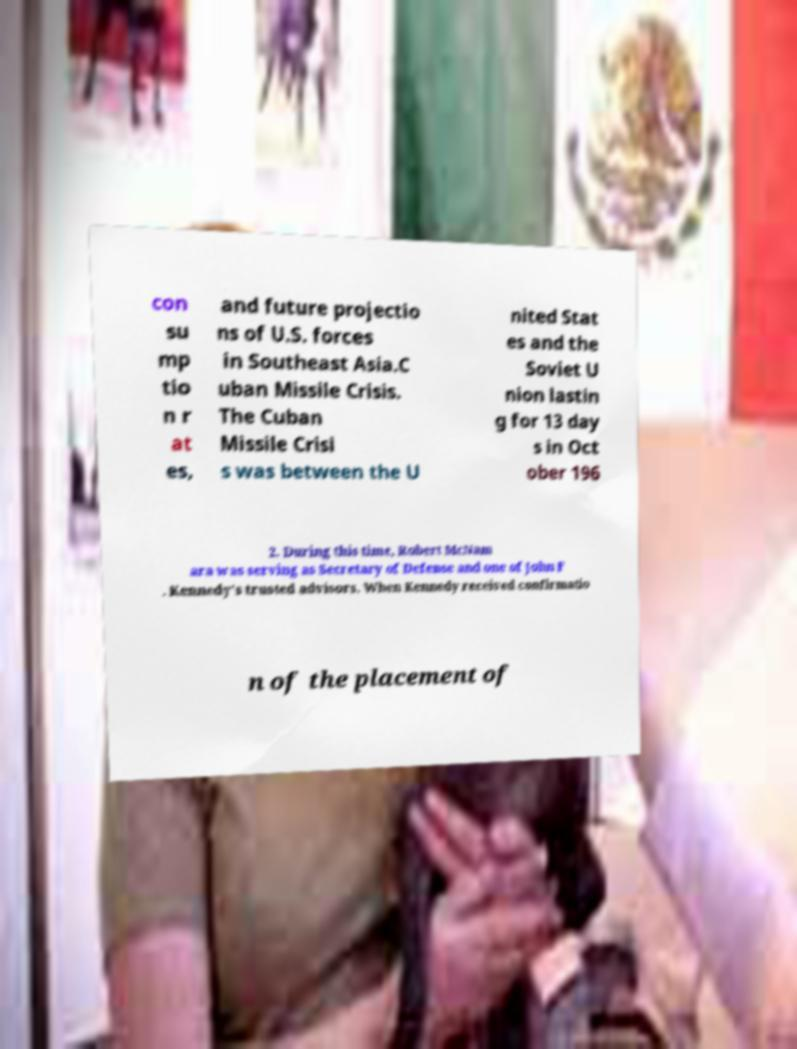There's text embedded in this image that I need extracted. Can you transcribe it verbatim? con su mp tio n r at es, and future projectio ns of U.S. forces in Southeast Asia.C uban Missile Crisis. The Cuban Missile Crisi s was between the U nited Stat es and the Soviet U nion lastin g for 13 day s in Oct ober 196 2. During this time, Robert McNam ara was serving as Secretary of Defense and one of John F . Kennedy's trusted advisors. When Kennedy received confirmatio n of the placement of 